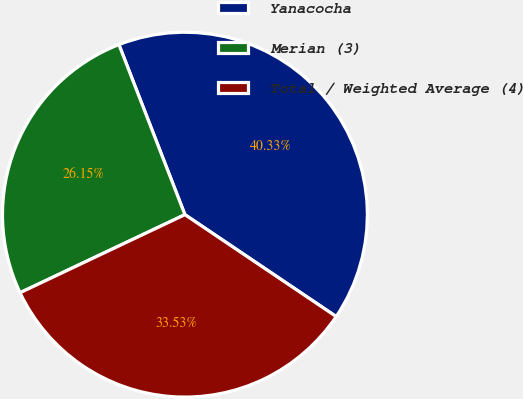<chart> <loc_0><loc_0><loc_500><loc_500><pie_chart><fcel>Yanacocha<fcel>Merian (3)<fcel>Total / Weighted Average (4)<nl><fcel>40.33%<fcel>26.15%<fcel>33.53%<nl></chart> 